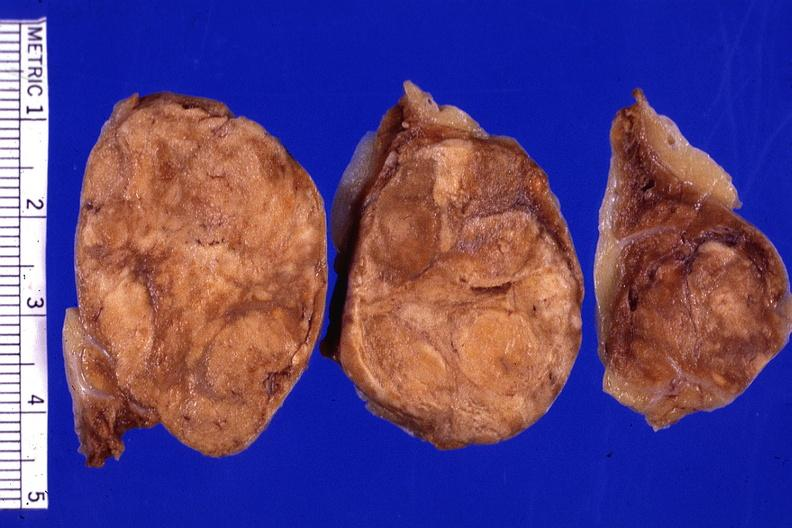s endocrine present?
Answer the question using a single word or phrase. Yes 